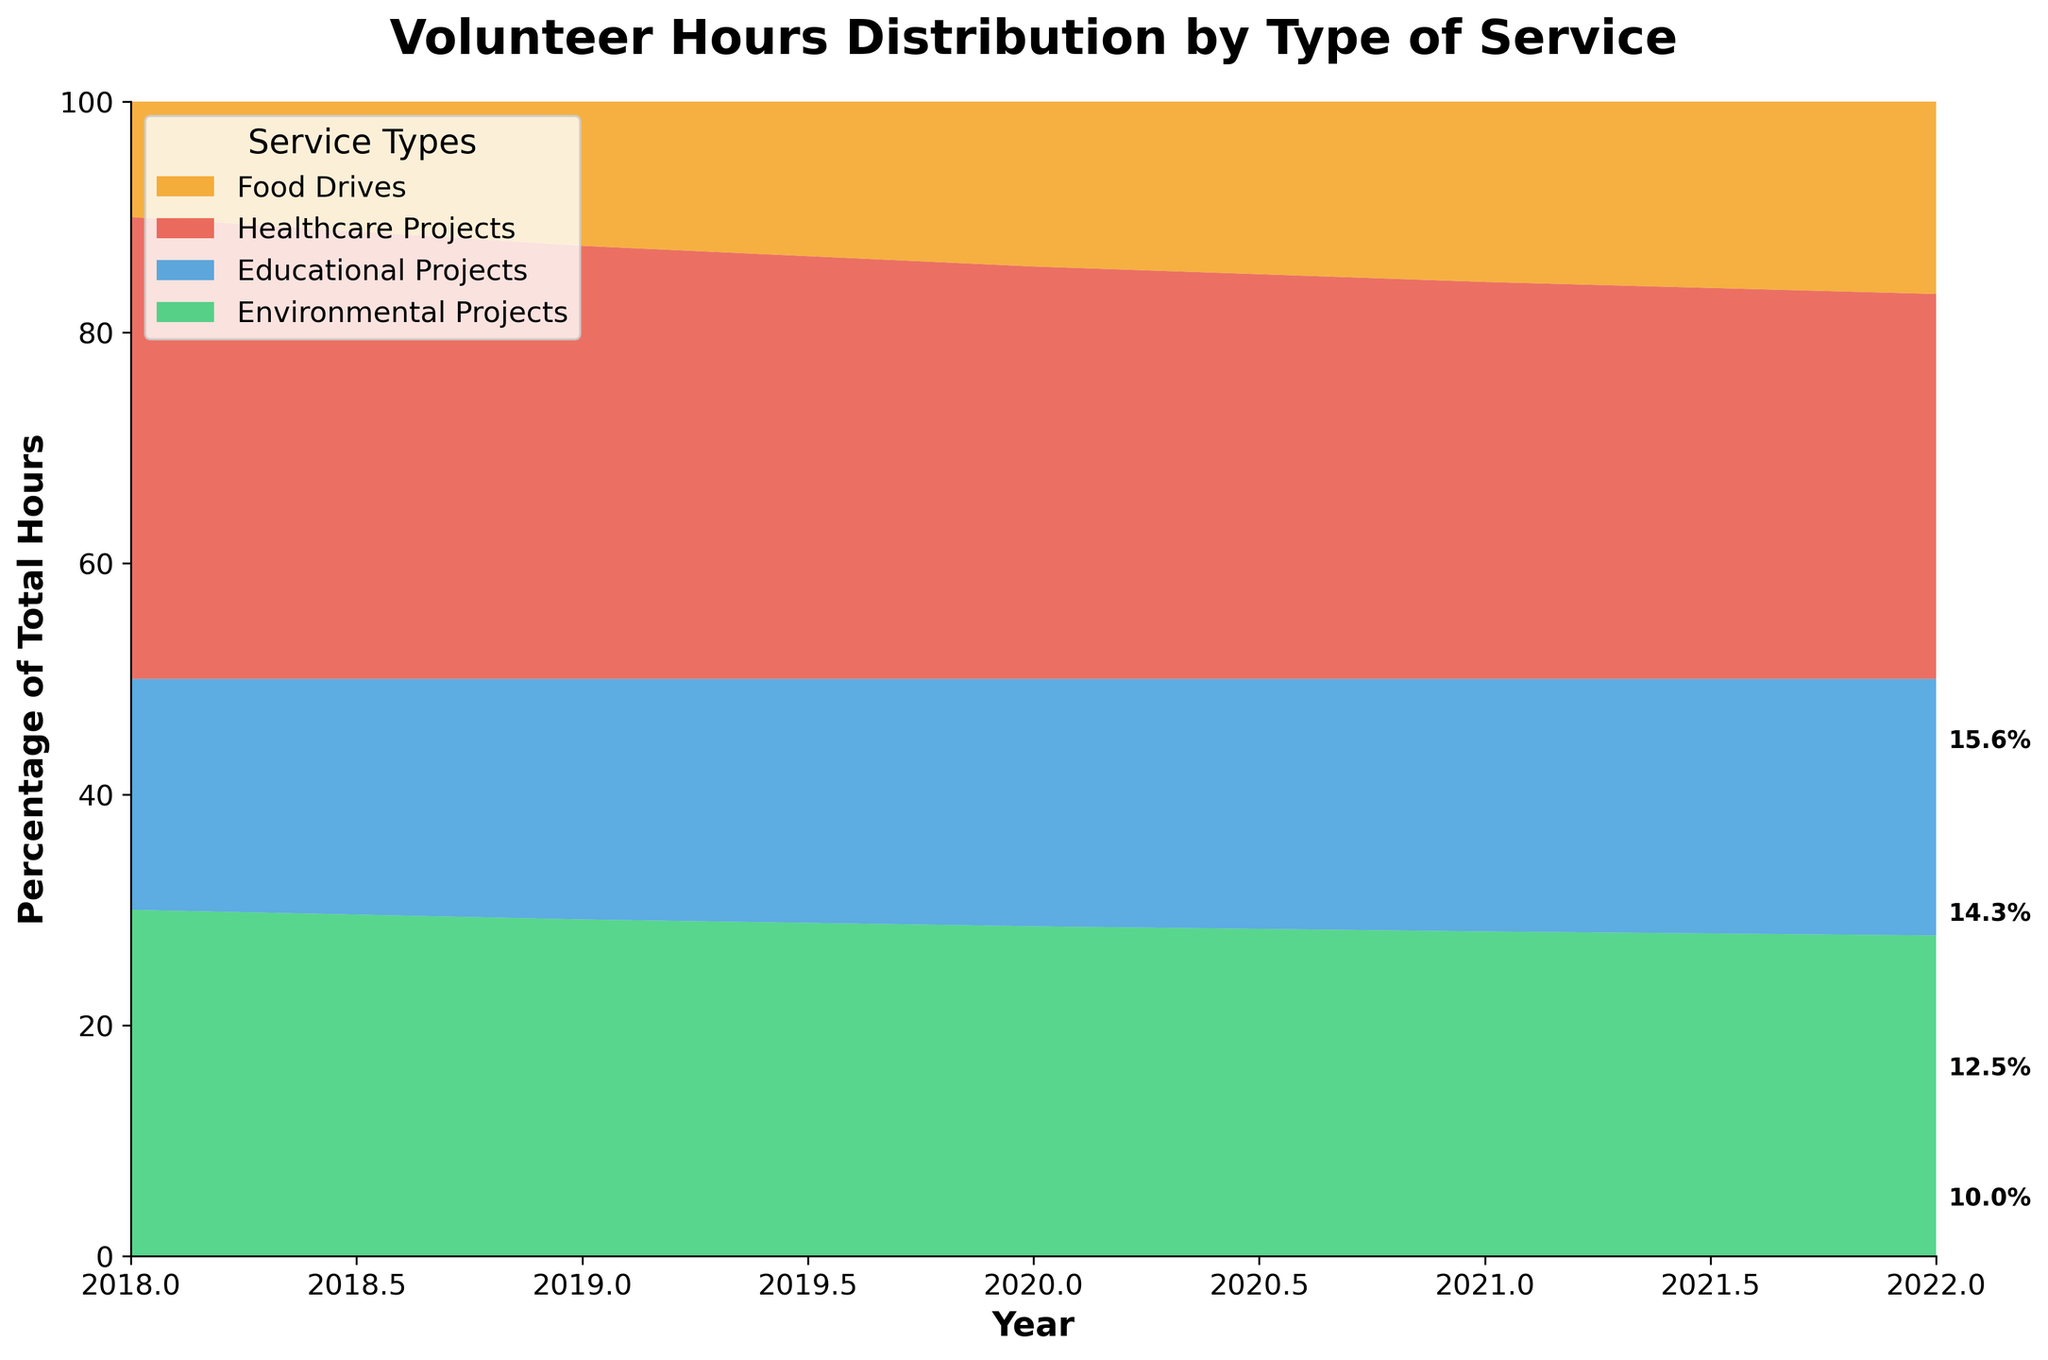What is the title of the chart? The title of the chart is prominently displayed at the top. It reads "Volunteer Hours Distribution by Type of Service".
Answer: Volunteer Hours Distribution by Type of Service Which service type had the highest percentage of volunteer hours in 2022? The chart shows different service types in separate colors, with their percentages annotated. The largest section in 2022 is for ‘Healthcare Projects’, which has the highest percentage.
Answer: Healthcare Projects What is the percentage of volunteer hours dedicated to Food Drives in 2018? To find this, look at the chart for the year 2018 and identify the portion colored in for Food Drives. According to the annotations at the end of the section, it is 7.1%.
Answer: 7.1% How has the percentage of volunteer hours for Educational Projects changed from 2018 to 2022? To answer this, compare the sections related to Educational Projects in the years 2018 and 2022. In 2018, it was 22.2%, and in 2022, it is 22.2%. Therefore, the percentage remains unchanged.
Answer: Unchanged (22.2% in both years) Compare the percentage of volunteer hours for Environmental Projects in 2020 and 2022. Which had a higher percentage and by how much? In 2020, the chart shows Environmental Projects have 28.6% of the total volunteer hours, and in 2022, it shows 29.4%. The difference is 29.4% - 28.6% = 0.8%.
Answer: 2022 by 0.8% What was the trend in volunteer hours for Healthcare Projects from 2018 to 2022? To identify the trend, observe the percentage of the Healthcare Projects section for each year. The trend indicates an increase: from 28.6% in 2018, it rose consistently each year, reaching 35.3% in 2022.
Answer: Increasing trend Which year had the lowest percentage of volunteer hours dedicated to Food Drives? Examine the size of the Food Drives sections across all years. The smallest section appears in 2018.
Answer: 2018 What portion of the total volunteer hours were dedicated to Environmental Projects in 2021? For 2021, identify the section corresponding to Environmental Projects. By looking at the percentage annotated, it indicates that Environmental Projects accounted for 29.4% of the total volunteer hours.
Answer: 29.4% 